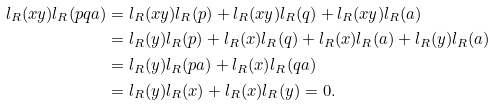Convert formula to latex. <formula><loc_0><loc_0><loc_500><loc_500>l _ { R } ( x y ) l _ { R } ( p q a ) & = l _ { R } ( x y ) l _ { R } ( p ) + l _ { R } ( x y ) l _ { R } ( q ) + l _ { R } ( x y ) l _ { R } ( a ) \\ & = l _ { R } ( y ) l _ { R } ( p ) + l _ { R } ( x ) l _ { R } ( q ) + l _ { R } ( x ) l _ { R } ( a ) + l _ { R } ( y ) l _ { R } ( a ) \\ & = l _ { R } ( y ) l _ { R } ( p a ) + l _ { R } ( x ) l _ { R } ( q a ) \\ & = l _ { R } ( y ) l _ { R } ( x ) + l _ { R } ( x ) l _ { R } ( y ) = 0 .</formula> 